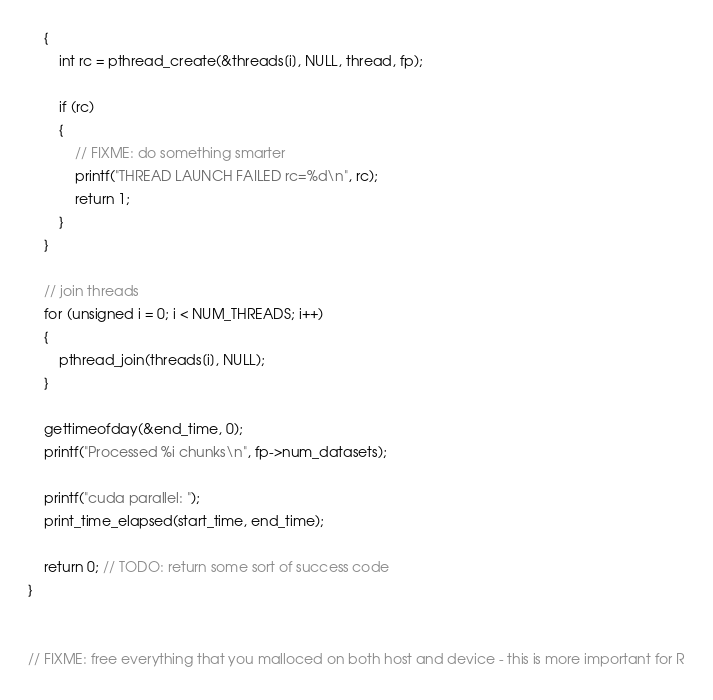<code> <loc_0><loc_0><loc_500><loc_500><_Cuda_>    {
        int rc = pthread_create(&threads[i], NULL, thread, fp);

        if (rc)
        {
            // FIXME: do something smarter
            printf("THREAD LAUNCH FAILED rc=%d\n", rc);
            return 1;
        }
    }

    // join threads
    for (unsigned i = 0; i < NUM_THREADS; i++)
    {
        pthread_join(threads[i], NULL);
    }

    gettimeofday(&end_time, 0);
    printf("Processed %i chunks\n", fp->num_datasets);

    printf("cuda parallel: ");
    print_time_elapsed(start_time, end_time);

    return 0; // TODO: return some sort of success code
}


// FIXME: free everything that you malloced on both host and device - this is more important for R
</code> 